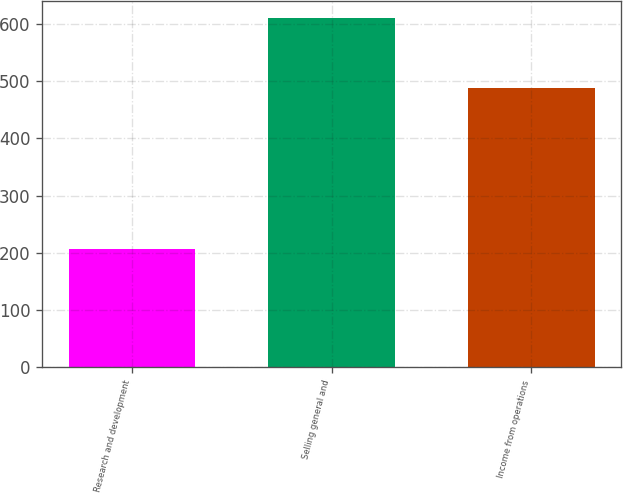Convert chart. <chart><loc_0><loc_0><loc_500><loc_500><bar_chart><fcel>Research and development<fcel>Selling general and<fcel>Income from operations<nl><fcel>206<fcel>610<fcel>487<nl></chart> 